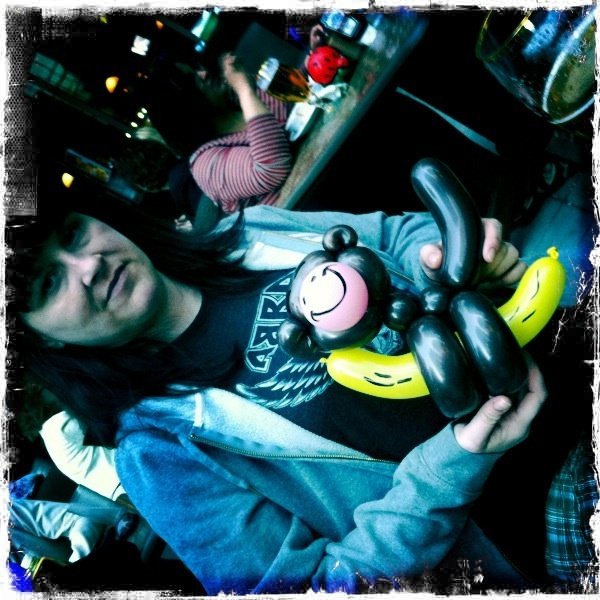Describe the objects in this image and their specific colors. I can see people in white, black, teal, and blue tones, people in white, black, gray, and darkgray tones, wine glass in white, black, teal, and darkgreen tones, banana in white, yellow, khaki, and black tones, and dining table in white, black, and teal tones in this image. 